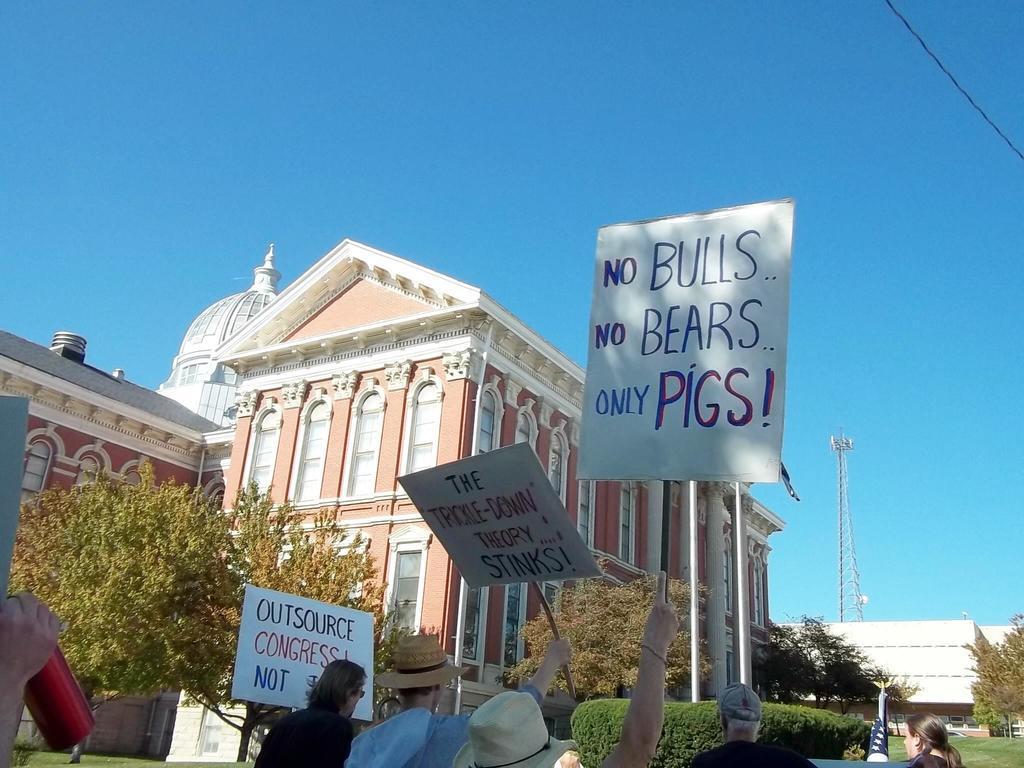How would you summarize this image in a sentence or two? In this picture I can see there are few buildings and there are trees and plants. There are few people standing and they are holding boards and there is a tower in the backdrop and the sky is clear. 